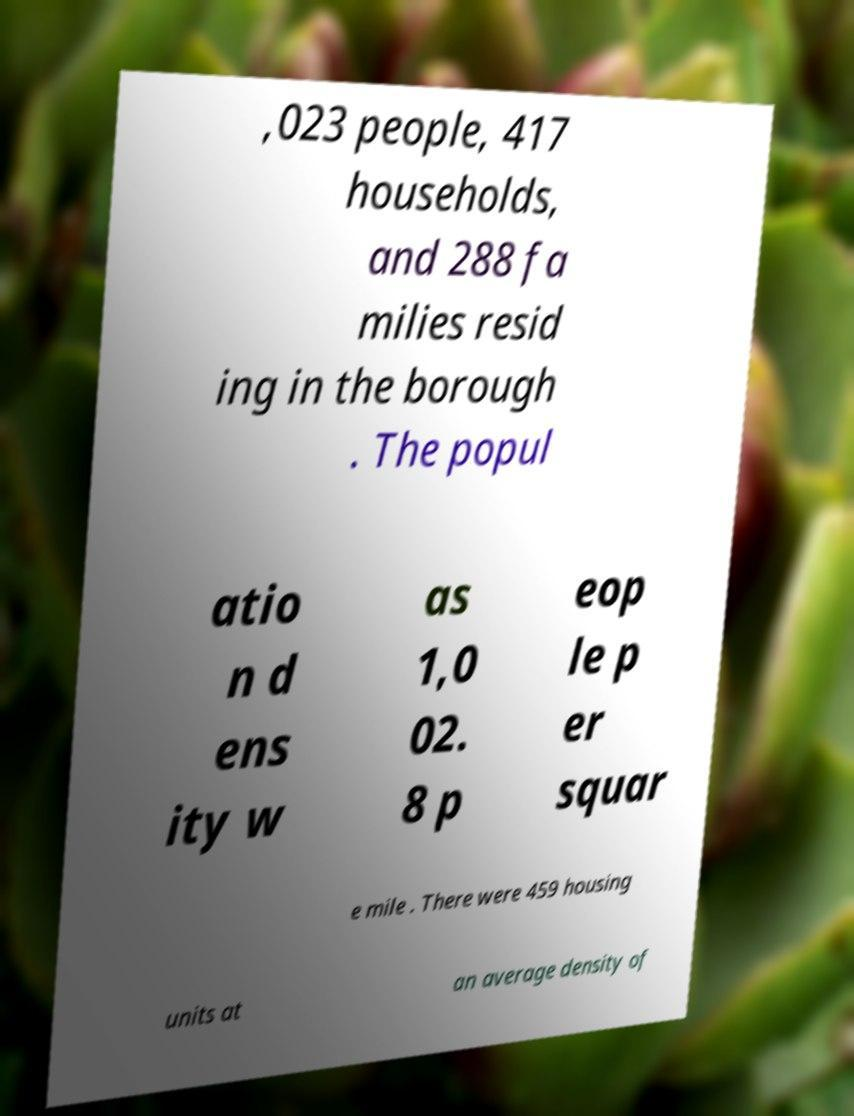Can you accurately transcribe the text from the provided image for me? ,023 people, 417 households, and 288 fa milies resid ing in the borough . The popul atio n d ens ity w as 1,0 02. 8 p eop le p er squar e mile . There were 459 housing units at an average density of 